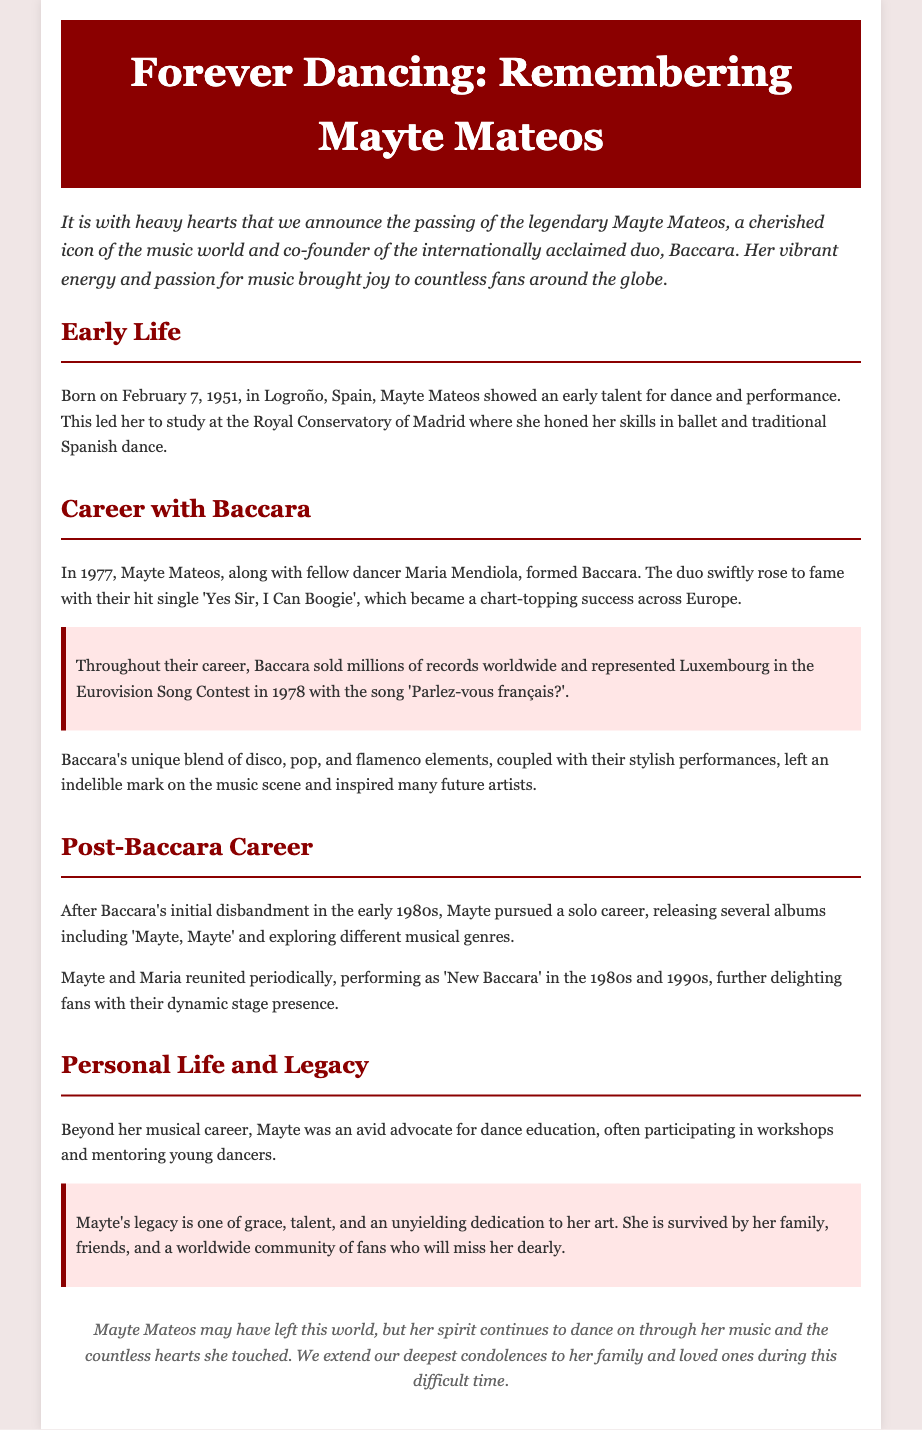what is the date of birth of Mayte Mateos? Mayte Mateos was born on February 7, 1951, as mentioned in the Early Life section.
Answer: February 7, 1951 what was Baccara's first hit single? The document states that their hit single was 'Yes Sir, I Can Boogie'.
Answer: Yes Sir, I Can Boogie which contest did Baccara represent Luxembourg? According to the Career with Baccara section, they represented Luxembourg in the Eurovision Song Contest in 1978.
Answer: Eurovision Song Contest what did Mayte pursue after the initial disbandment of Baccara? The Post-Baccara Career section notes that Mayte pursued a solo career, releasing several albums.
Answer: Solo career how is Mayte's legacy described in the obituary? The document highlights her legacy as one of grace, talent, and an unyielding dedication to her art.
Answer: Grace, talent, and dedication who formed Baccara with Mayte Mateos? The text specifies that Maria Mendiola formed Baccara alongside Mayte Mateos.
Answer: Maria Mendiola how did Mayte contribute to dance education? The obituary mentions that she participated in workshops and mentored young dancers.
Answer: Workshops and mentoring when was the initial disbandment of Baccara? The Post-Baccara Career section indicates it was in the early 1980s.
Answer: Early 1980s what emotional tone does the introduction of the obituary convey? The introduction expresses a tone of heavy hearts and sorrow for her passing.
Answer: Heavy hearts 